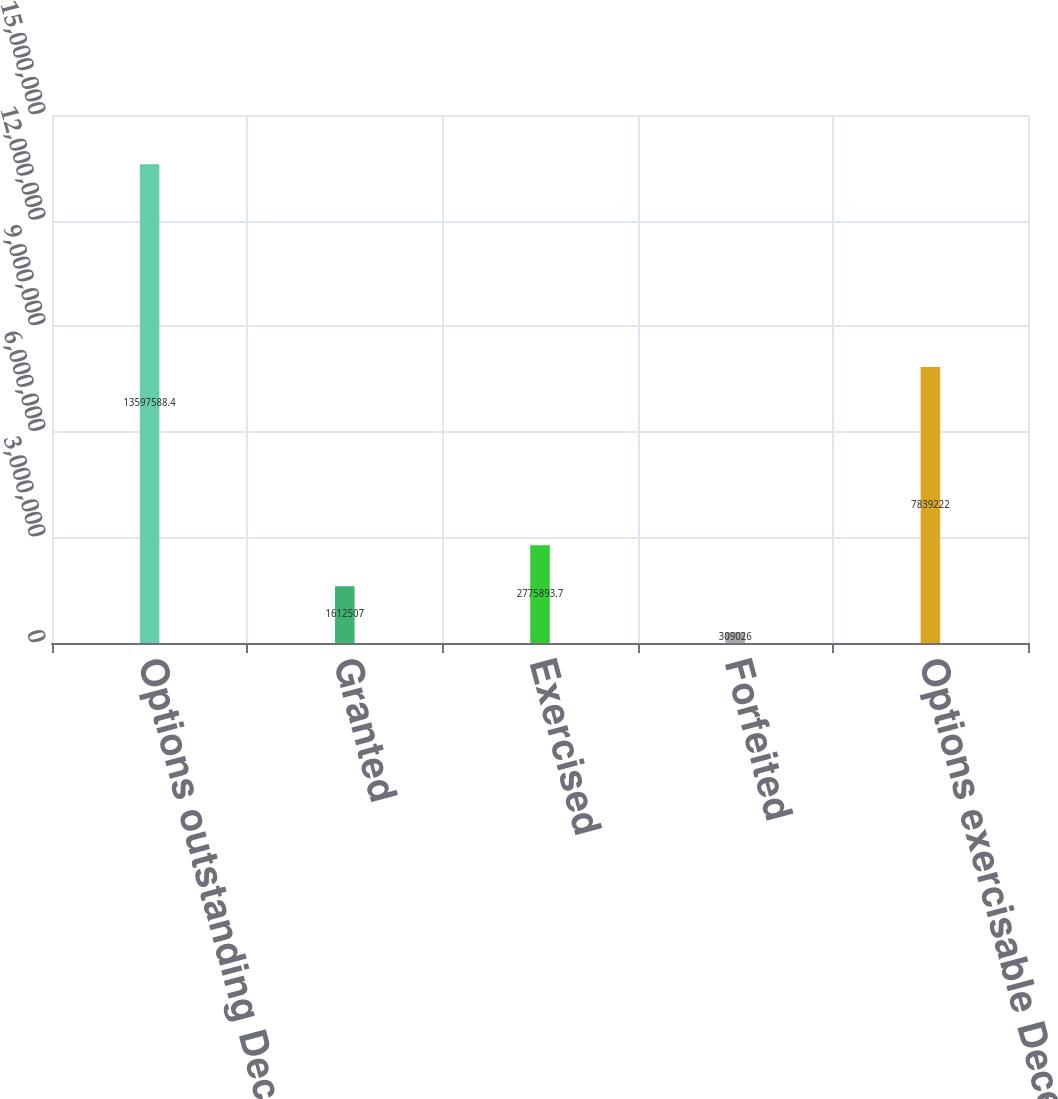Convert chart. <chart><loc_0><loc_0><loc_500><loc_500><bar_chart><fcel>Options outstanding December<fcel>Granted<fcel>Exercised<fcel>Forfeited<fcel>Options exercisable December<nl><fcel>1.35976e+07<fcel>1.61251e+06<fcel>2.77589e+06<fcel>309026<fcel>7.83922e+06<nl></chart> 